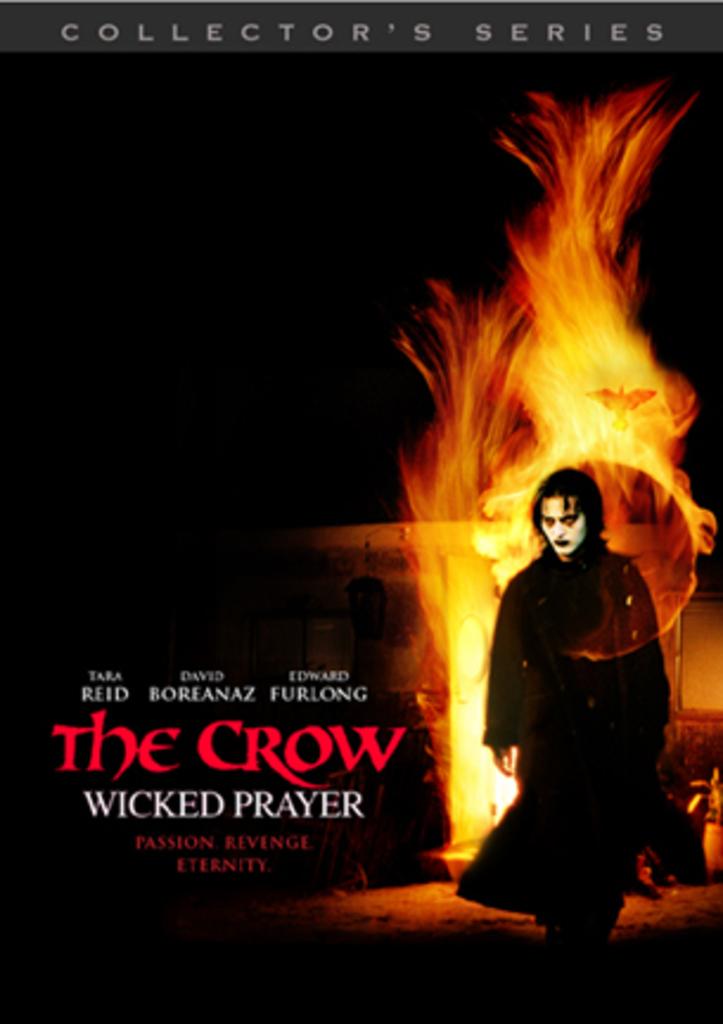What's the name of this movie?
Ensure brevity in your answer.  The crow. Who is in this?
Your response must be concise. Tara reid. 